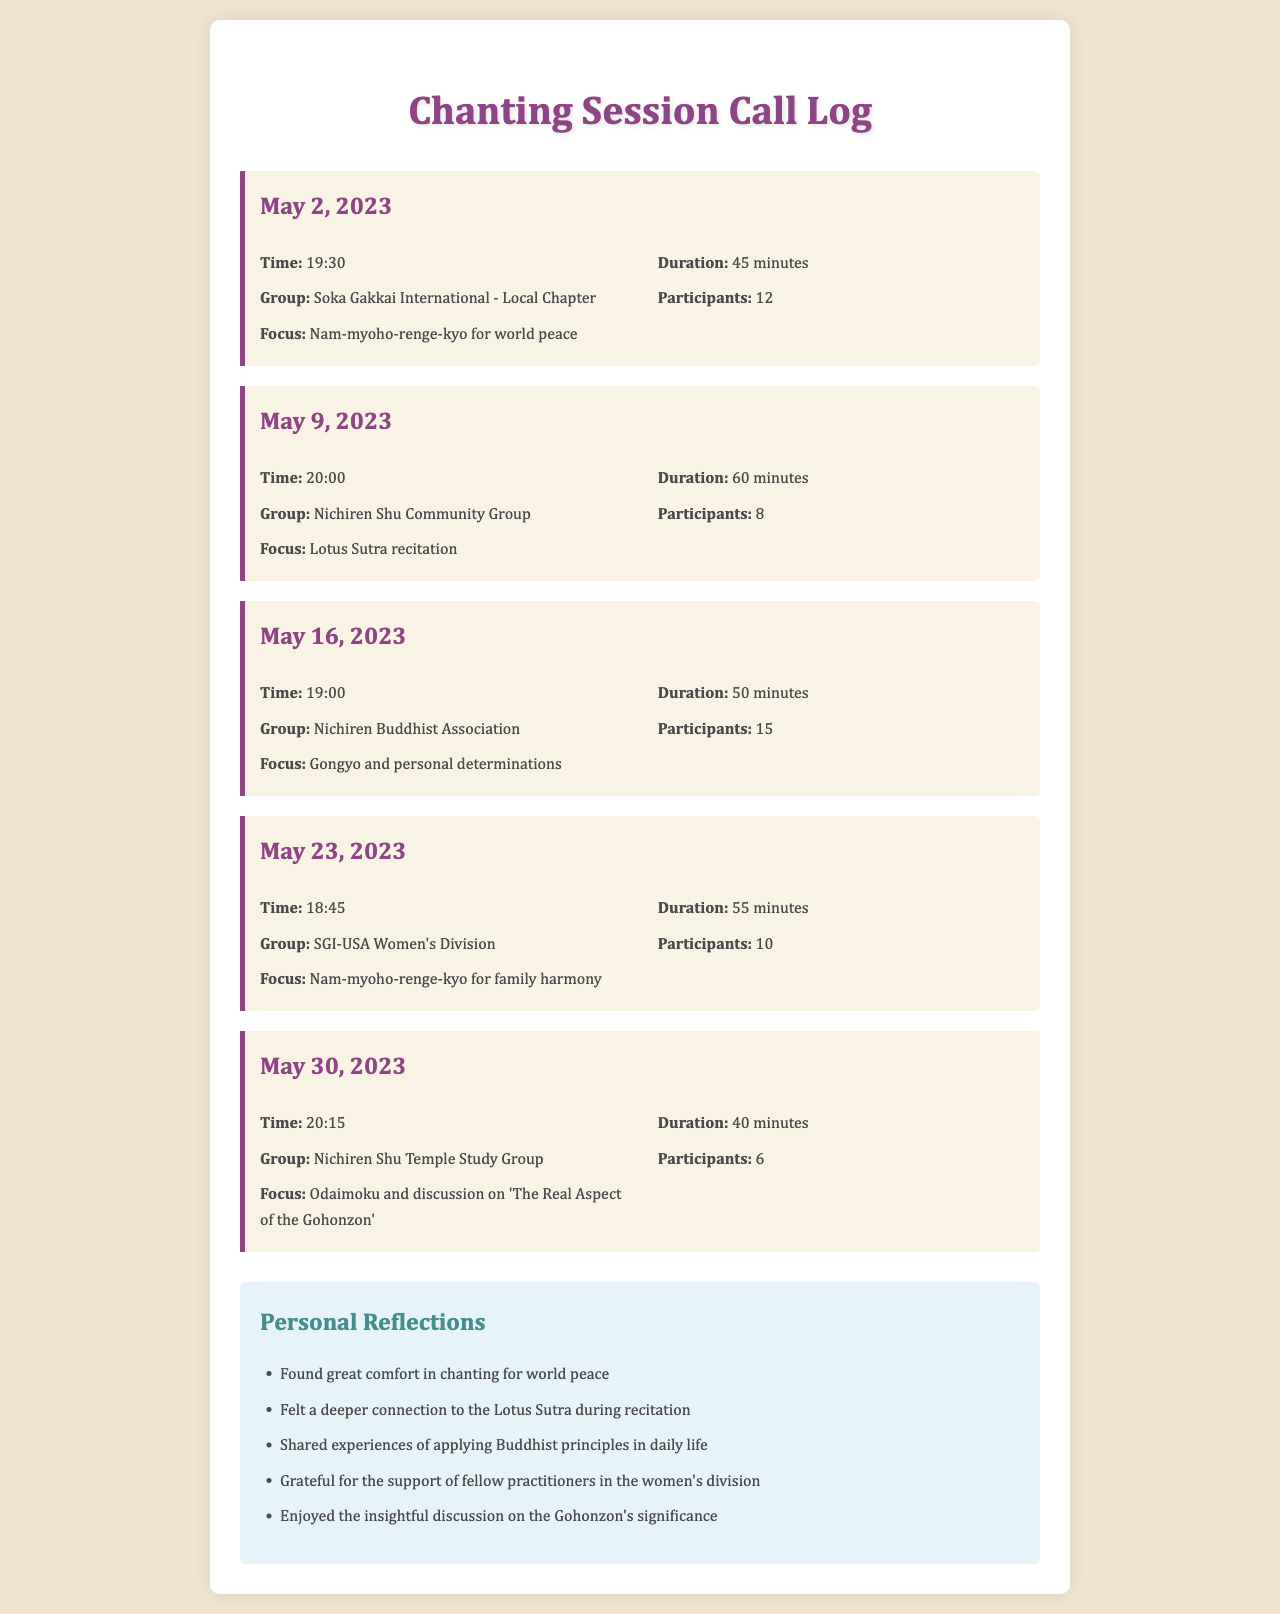What date was the first chanting session recorded? The first chanting session recorded in the document is on May 2, 2023.
Answer: May 2, 2023 How long did the session on May 9, 2023, last? The duration of the session on May 9, 2023, was 60 minutes.
Answer: 60 minutes What was the focus of the chanting on May 23, 2023? The focus for the chanting on May 23, 2023, was Nam-myoho-renge-kyo for family harmony.
Answer: Nam-myoho-renge-kyo for family harmony Which group had the most participants, and how many were there? The group with the most participants was the Nichiren Buddhist Association, with 15 participants.
Answer: Nichiren Buddhist Association, 15 How many sessions were recorded in total? The document lists a total of five chanting sessions.
Answer: 5 Which group focused on the Lotus Sutra? The group that focused on the Lotus Sutra was the Nichiren Shu Community Group.
Answer: Nichiren Shu Community Group Which session had the earliest time? The session with the earliest time was on May 30, 2023, at 20:15.
Answer: May 30, 2023, 20:15 What were the personal reflections about the Gohonzon? The personal reflection mentioned enjoying the insightful discussion on the Gohonzon's significance.
Answer: Enjoyed the insightful discussion on the Gohonzon's significance 